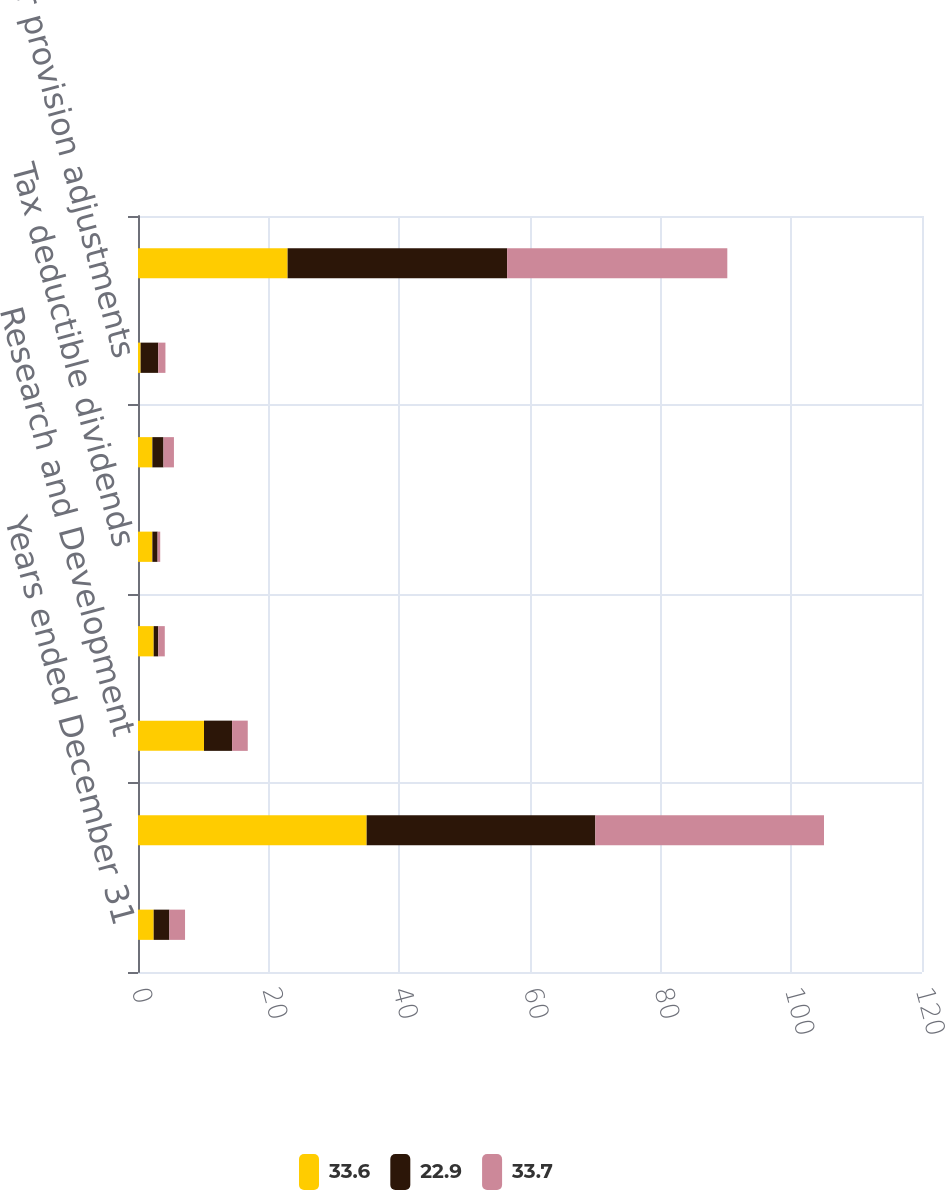Convert chart to OTSL. <chart><loc_0><loc_0><loc_500><loc_500><stacked_bar_chart><ecel><fcel>Years ended December 31<fcel>US federal statutory tax<fcel>Research and Development<fcel>Tax on international<fcel>Tax deductible dividends<fcel>State income tax provision net<fcel>Other provision adjustments<fcel>Effective income tax rate<nl><fcel>33.6<fcel>2.4<fcel>35<fcel>10.1<fcel>2.4<fcel>2.2<fcel>2.2<fcel>0.4<fcel>22.9<nl><fcel>22.9<fcel>2.4<fcel>35<fcel>4.3<fcel>0.7<fcel>0.8<fcel>1.7<fcel>2.7<fcel>33.6<nl><fcel>33.7<fcel>2.4<fcel>35<fcel>2.4<fcel>1<fcel>0.4<fcel>1.6<fcel>1.1<fcel>33.7<nl></chart> 